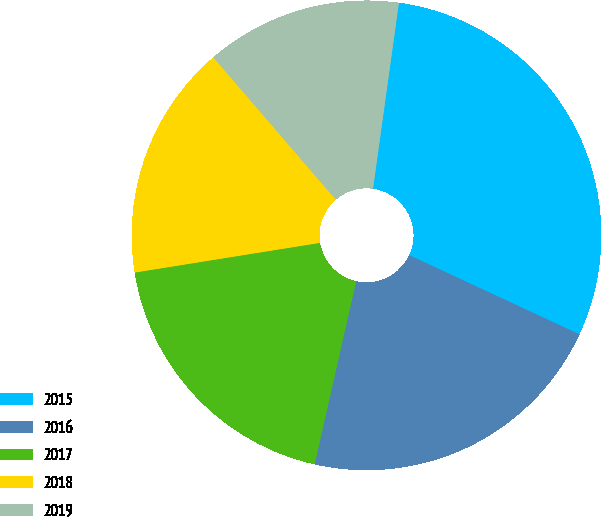Convert chart. <chart><loc_0><loc_0><loc_500><loc_500><pie_chart><fcel>2015<fcel>2016<fcel>2017<fcel>2018<fcel>2019<nl><fcel>29.73%<fcel>21.62%<fcel>18.92%<fcel>16.22%<fcel>13.51%<nl></chart> 